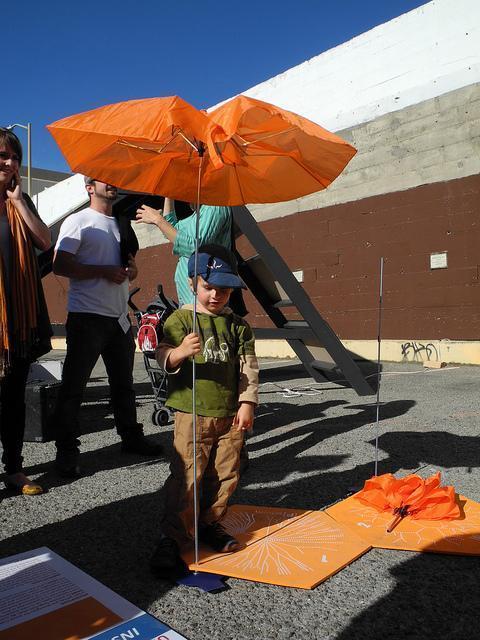How many umbrellas are in the photo?
Give a very brief answer. 2. How many people are there?
Give a very brief answer. 4. How many sinks are in the bathroom?
Give a very brief answer. 0. 